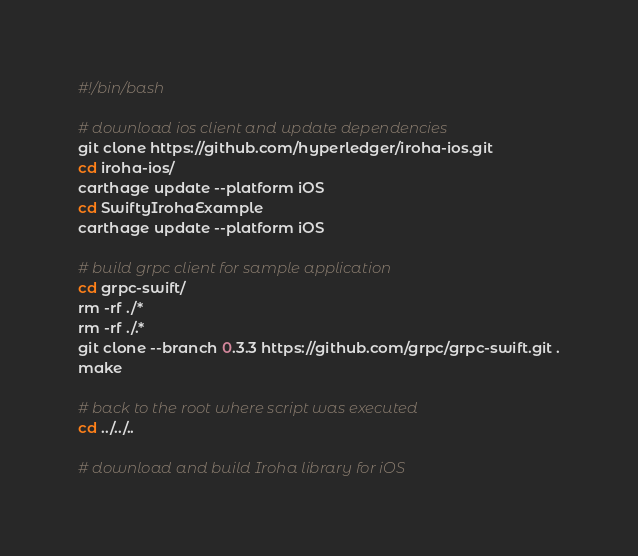Convert code to text. <code><loc_0><loc_0><loc_500><loc_500><_Bash_>#!/bin/bash

# download ios client and update dependencies
git clone https://github.com/hyperledger/iroha-ios.git
cd iroha-ios/
carthage update --platform iOS
cd SwiftyIrohaExample
carthage update --platform iOS

# build grpc client for sample application
cd grpc-swift/
rm -rf ./*
rm -rf ./.*
git clone --branch 0.3.3 https://github.com/grpc/grpc-swift.git .
make

# back to the root where script was executed
cd ../../..

# download and build Iroha library for iOS</code> 